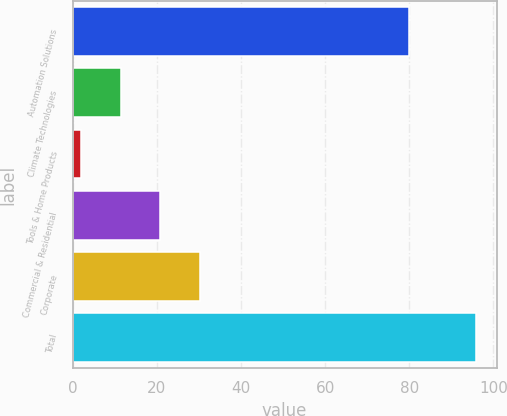<chart> <loc_0><loc_0><loc_500><loc_500><bar_chart><fcel>Automation Solutions<fcel>Climate Technologies<fcel>Tools & Home Products<fcel>Commercial & Residential<fcel>Corporate<fcel>Total<nl><fcel>80<fcel>11.4<fcel>2<fcel>20.8<fcel>30.2<fcel>96<nl></chart> 